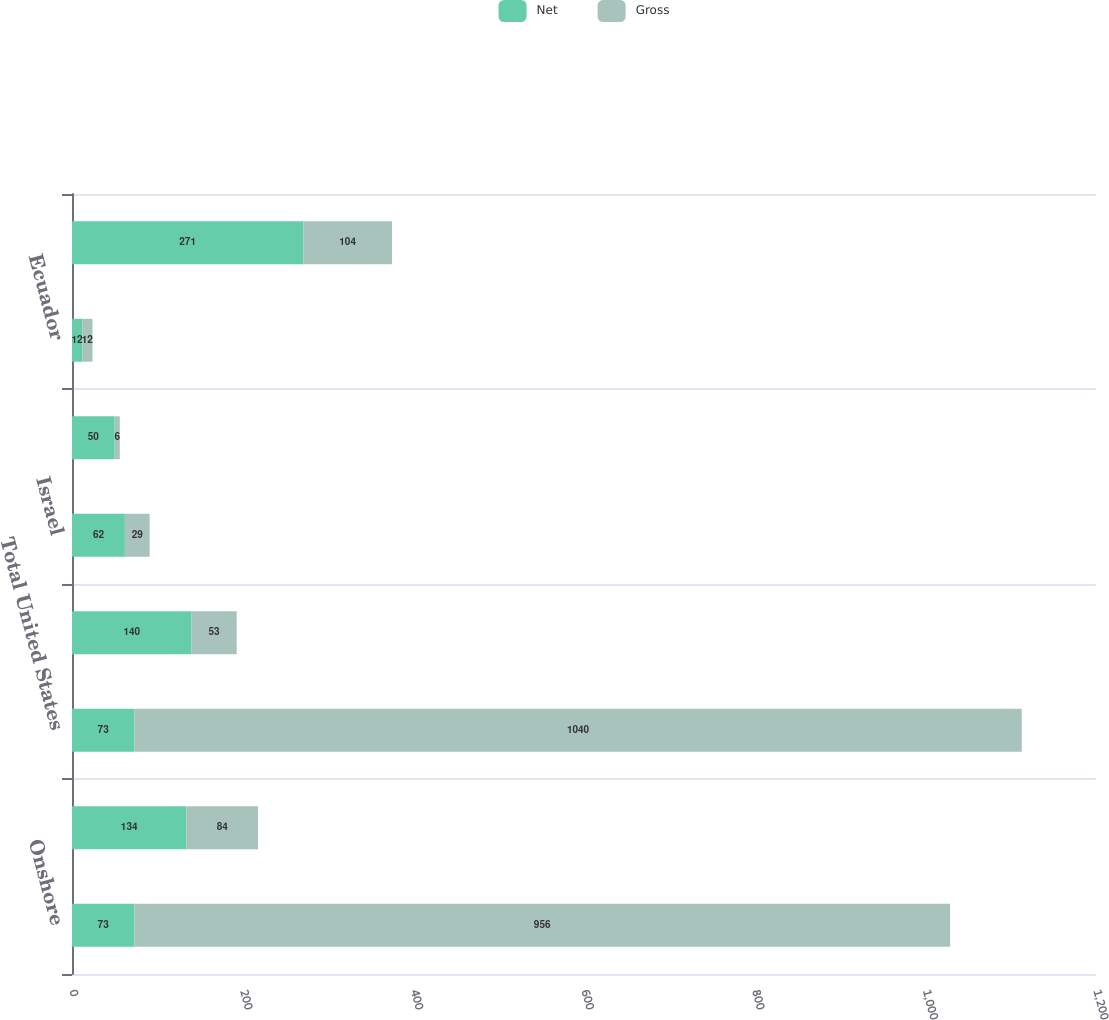Convert chart to OTSL. <chart><loc_0><loc_0><loc_500><loc_500><stacked_bar_chart><ecel><fcel>Onshore<fcel>Offshore<fcel>Total United States<fcel>Equatorial Guinea<fcel>Israel<fcel>North Sea (1)<fcel>Ecuador<fcel>Total International<nl><fcel>Net<fcel>73<fcel>134<fcel>73<fcel>140<fcel>62<fcel>50<fcel>12<fcel>271<nl><fcel>Gross<fcel>956<fcel>84<fcel>1040<fcel>53<fcel>29<fcel>6<fcel>12<fcel>104<nl></chart> 